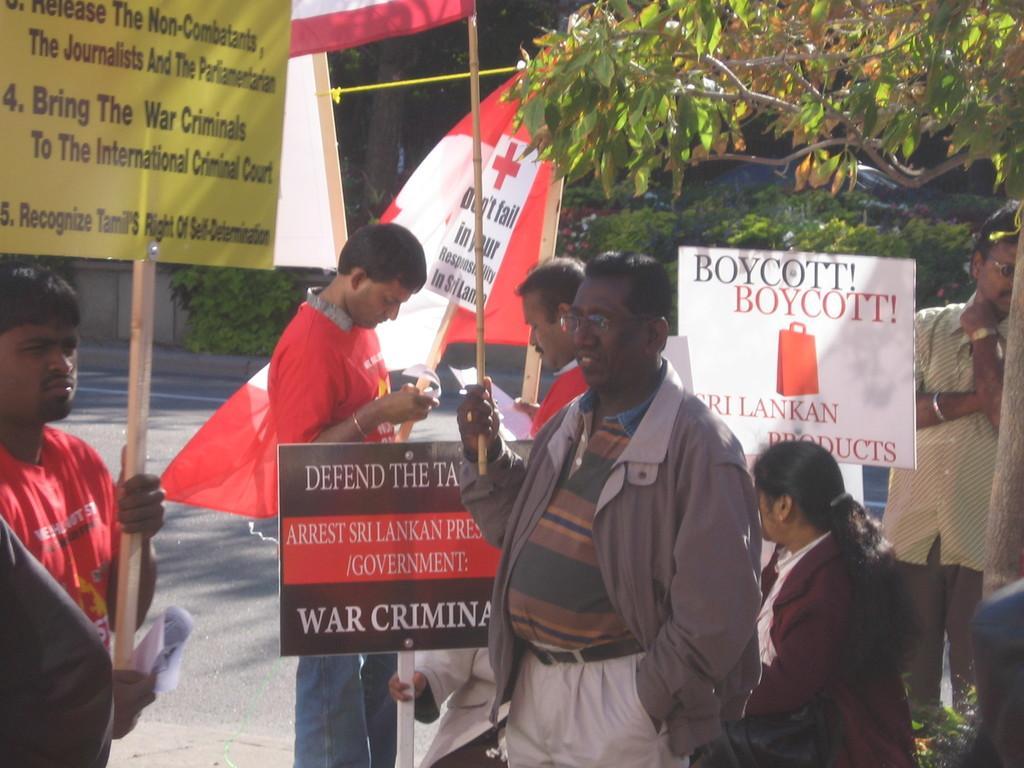Describe this image in one or two sentences. In this image I can see few persons are standing and holding boards in their hands. I can see few trees which are green in color in the background. 